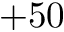<formula> <loc_0><loc_0><loc_500><loc_500>+ 5 0</formula> 